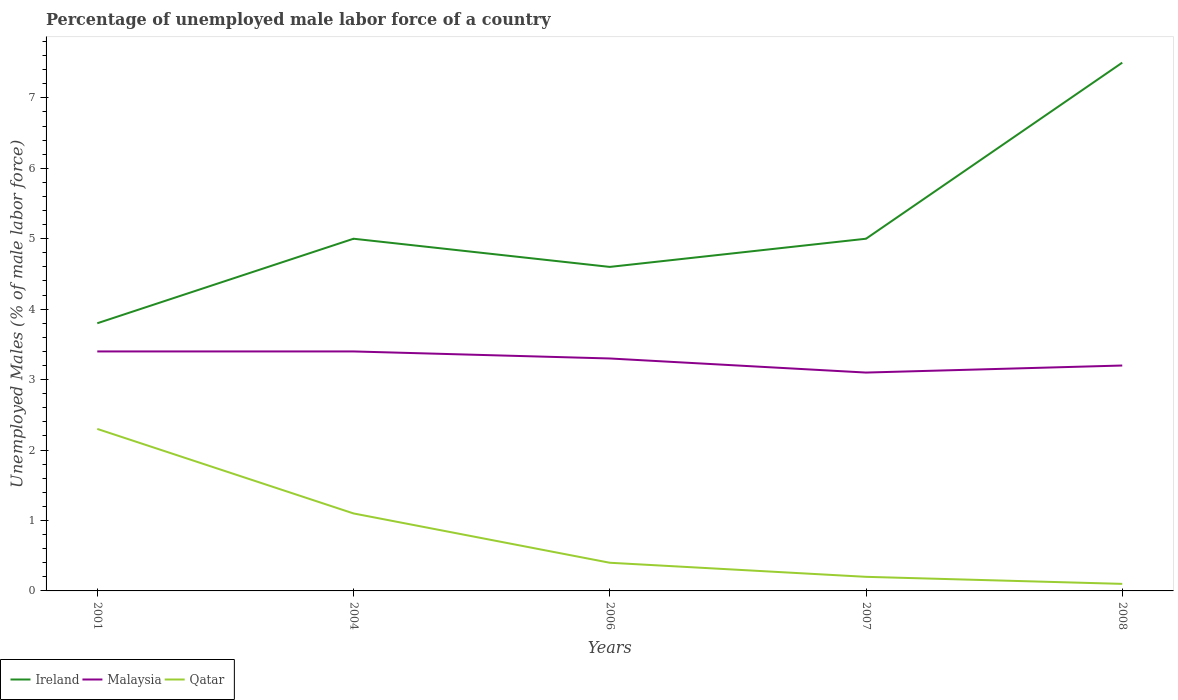How many different coloured lines are there?
Make the answer very short. 3. Is the number of lines equal to the number of legend labels?
Your answer should be very brief. Yes. Across all years, what is the maximum percentage of unemployed male labor force in Ireland?
Your answer should be compact. 3.8. In which year was the percentage of unemployed male labor force in Qatar maximum?
Your response must be concise. 2008. What is the total percentage of unemployed male labor force in Qatar in the graph?
Your answer should be compact. 1. What is the difference between the highest and the second highest percentage of unemployed male labor force in Qatar?
Offer a terse response. 2.2. What is the difference between the highest and the lowest percentage of unemployed male labor force in Ireland?
Your response must be concise. 1. Is the percentage of unemployed male labor force in Ireland strictly greater than the percentage of unemployed male labor force in Malaysia over the years?
Offer a terse response. No. How many years are there in the graph?
Make the answer very short. 5. Does the graph contain any zero values?
Your response must be concise. No. Where does the legend appear in the graph?
Your answer should be compact. Bottom left. How many legend labels are there?
Give a very brief answer. 3. What is the title of the graph?
Your answer should be compact. Percentage of unemployed male labor force of a country. Does "Austria" appear as one of the legend labels in the graph?
Your response must be concise. No. What is the label or title of the X-axis?
Provide a short and direct response. Years. What is the label or title of the Y-axis?
Your response must be concise. Unemployed Males (% of male labor force). What is the Unemployed Males (% of male labor force) in Ireland in 2001?
Make the answer very short. 3.8. What is the Unemployed Males (% of male labor force) of Malaysia in 2001?
Your answer should be compact. 3.4. What is the Unemployed Males (% of male labor force) of Qatar in 2001?
Your response must be concise. 2.3. What is the Unemployed Males (% of male labor force) in Ireland in 2004?
Offer a terse response. 5. What is the Unemployed Males (% of male labor force) of Malaysia in 2004?
Your response must be concise. 3.4. What is the Unemployed Males (% of male labor force) of Qatar in 2004?
Your response must be concise. 1.1. What is the Unemployed Males (% of male labor force) in Ireland in 2006?
Ensure brevity in your answer.  4.6. What is the Unemployed Males (% of male labor force) in Malaysia in 2006?
Provide a succinct answer. 3.3. What is the Unemployed Males (% of male labor force) in Qatar in 2006?
Offer a terse response. 0.4. What is the Unemployed Males (% of male labor force) of Ireland in 2007?
Your answer should be very brief. 5. What is the Unemployed Males (% of male labor force) in Malaysia in 2007?
Ensure brevity in your answer.  3.1. What is the Unemployed Males (% of male labor force) in Qatar in 2007?
Provide a succinct answer. 0.2. What is the Unemployed Males (% of male labor force) of Malaysia in 2008?
Offer a terse response. 3.2. What is the Unemployed Males (% of male labor force) in Qatar in 2008?
Provide a succinct answer. 0.1. Across all years, what is the maximum Unemployed Males (% of male labor force) in Malaysia?
Provide a short and direct response. 3.4. Across all years, what is the maximum Unemployed Males (% of male labor force) in Qatar?
Keep it short and to the point. 2.3. Across all years, what is the minimum Unemployed Males (% of male labor force) of Ireland?
Your response must be concise. 3.8. Across all years, what is the minimum Unemployed Males (% of male labor force) of Malaysia?
Give a very brief answer. 3.1. Across all years, what is the minimum Unemployed Males (% of male labor force) of Qatar?
Offer a terse response. 0.1. What is the total Unemployed Males (% of male labor force) in Ireland in the graph?
Provide a succinct answer. 25.9. What is the total Unemployed Males (% of male labor force) of Malaysia in the graph?
Provide a short and direct response. 16.4. What is the difference between the Unemployed Males (% of male labor force) of Malaysia in 2001 and that in 2004?
Your answer should be compact. 0. What is the difference between the Unemployed Males (% of male labor force) of Ireland in 2001 and that in 2006?
Ensure brevity in your answer.  -0.8. What is the difference between the Unemployed Males (% of male labor force) of Malaysia in 2001 and that in 2006?
Your answer should be very brief. 0.1. What is the difference between the Unemployed Males (% of male labor force) of Qatar in 2001 and that in 2006?
Your response must be concise. 1.9. What is the difference between the Unemployed Males (% of male labor force) of Malaysia in 2001 and that in 2007?
Provide a succinct answer. 0.3. What is the difference between the Unemployed Males (% of male labor force) in Qatar in 2001 and that in 2007?
Offer a very short reply. 2.1. What is the difference between the Unemployed Males (% of male labor force) of Malaysia in 2001 and that in 2008?
Give a very brief answer. 0.2. What is the difference between the Unemployed Males (% of male labor force) of Malaysia in 2004 and that in 2006?
Provide a succinct answer. 0.1. What is the difference between the Unemployed Males (% of male labor force) in Qatar in 2004 and that in 2006?
Offer a terse response. 0.7. What is the difference between the Unemployed Males (% of male labor force) in Qatar in 2004 and that in 2007?
Offer a terse response. 0.9. What is the difference between the Unemployed Males (% of male labor force) in Malaysia in 2004 and that in 2008?
Keep it short and to the point. 0.2. What is the difference between the Unemployed Males (% of male labor force) of Qatar in 2004 and that in 2008?
Your answer should be very brief. 1. What is the difference between the Unemployed Males (% of male labor force) in Malaysia in 2006 and that in 2007?
Your response must be concise. 0.2. What is the difference between the Unemployed Males (% of male labor force) in Ireland in 2006 and that in 2008?
Make the answer very short. -2.9. What is the difference between the Unemployed Males (% of male labor force) of Malaysia in 2006 and that in 2008?
Provide a succinct answer. 0.1. What is the difference between the Unemployed Males (% of male labor force) in Ireland in 2007 and that in 2008?
Give a very brief answer. -2.5. What is the difference between the Unemployed Males (% of male labor force) of Malaysia in 2007 and that in 2008?
Your answer should be compact. -0.1. What is the difference between the Unemployed Males (% of male labor force) in Qatar in 2007 and that in 2008?
Your response must be concise. 0.1. What is the difference between the Unemployed Males (% of male labor force) of Ireland in 2001 and the Unemployed Males (% of male labor force) of Malaysia in 2004?
Give a very brief answer. 0.4. What is the difference between the Unemployed Males (% of male labor force) of Ireland in 2001 and the Unemployed Males (% of male labor force) of Malaysia in 2006?
Your response must be concise. 0.5. What is the difference between the Unemployed Males (% of male labor force) in Malaysia in 2001 and the Unemployed Males (% of male labor force) in Qatar in 2006?
Keep it short and to the point. 3. What is the difference between the Unemployed Males (% of male labor force) in Ireland in 2001 and the Unemployed Males (% of male labor force) in Qatar in 2008?
Keep it short and to the point. 3.7. What is the difference between the Unemployed Males (% of male labor force) in Malaysia in 2001 and the Unemployed Males (% of male labor force) in Qatar in 2008?
Your answer should be compact. 3.3. What is the difference between the Unemployed Males (% of male labor force) of Malaysia in 2004 and the Unemployed Males (% of male labor force) of Qatar in 2007?
Offer a very short reply. 3.2. What is the difference between the Unemployed Males (% of male labor force) of Ireland in 2004 and the Unemployed Males (% of male labor force) of Malaysia in 2008?
Your answer should be compact. 1.8. What is the difference between the Unemployed Males (% of male labor force) of Ireland in 2004 and the Unemployed Males (% of male labor force) of Qatar in 2008?
Your answer should be compact. 4.9. What is the difference between the Unemployed Males (% of male labor force) of Ireland in 2006 and the Unemployed Males (% of male labor force) of Qatar in 2008?
Your response must be concise. 4.5. What is the difference between the Unemployed Males (% of male labor force) of Ireland in 2007 and the Unemployed Males (% of male labor force) of Malaysia in 2008?
Offer a very short reply. 1.8. What is the difference between the Unemployed Males (% of male labor force) in Malaysia in 2007 and the Unemployed Males (% of male labor force) in Qatar in 2008?
Offer a terse response. 3. What is the average Unemployed Males (% of male labor force) of Ireland per year?
Give a very brief answer. 5.18. What is the average Unemployed Males (% of male labor force) in Malaysia per year?
Offer a very short reply. 3.28. What is the average Unemployed Males (% of male labor force) in Qatar per year?
Keep it short and to the point. 0.82. In the year 2001, what is the difference between the Unemployed Males (% of male labor force) of Ireland and Unemployed Males (% of male labor force) of Malaysia?
Keep it short and to the point. 0.4. In the year 2001, what is the difference between the Unemployed Males (% of male labor force) in Ireland and Unemployed Males (% of male labor force) in Qatar?
Offer a very short reply. 1.5. In the year 2001, what is the difference between the Unemployed Males (% of male labor force) in Malaysia and Unemployed Males (% of male labor force) in Qatar?
Ensure brevity in your answer.  1.1. In the year 2004, what is the difference between the Unemployed Males (% of male labor force) in Ireland and Unemployed Males (% of male labor force) in Malaysia?
Keep it short and to the point. 1.6. In the year 2006, what is the difference between the Unemployed Males (% of male labor force) of Ireland and Unemployed Males (% of male labor force) of Malaysia?
Your answer should be very brief. 1.3. In the year 2006, what is the difference between the Unemployed Males (% of male labor force) of Malaysia and Unemployed Males (% of male labor force) of Qatar?
Provide a succinct answer. 2.9. In the year 2008, what is the difference between the Unemployed Males (% of male labor force) in Malaysia and Unemployed Males (% of male labor force) in Qatar?
Your answer should be very brief. 3.1. What is the ratio of the Unemployed Males (% of male labor force) of Ireland in 2001 to that in 2004?
Ensure brevity in your answer.  0.76. What is the ratio of the Unemployed Males (% of male labor force) in Malaysia in 2001 to that in 2004?
Your answer should be compact. 1. What is the ratio of the Unemployed Males (% of male labor force) of Qatar in 2001 to that in 2004?
Your answer should be very brief. 2.09. What is the ratio of the Unemployed Males (% of male labor force) in Ireland in 2001 to that in 2006?
Your response must be concise. 0.83. What is the ratio of the Unemployed Males (% of male labor force) of Malaysia in 2001 to that in 2006?
Your response must be concise. 1.03. What is the ratio of the Unemployed Males (% of male labor force) of Qatar in 2001 to that in 2006?
Your response must be concise. 5.75. What is the ratio of the Unemployed Males (% of male labor force) in Ireland in 2001 to that in 2007?
Provide a succinct answer. 0.76. What is the ratio of the Unemployed Males (% of male labor force) of Malaysia in 2001 to that in 2007?
Your answer should be compact. 1.1. What is the ratio of the Unemployed Males (% of male labor force) of Ireland in 2001 to that in 2008?
Make the answer very short. 0.51. What is the ratio of the Unemployed Males (% of male labor force) of Malaysia in 2001 to that in 2008?
Your answer should be very brief. 1.06. What is the ratio of the Unemployed Males (% of male labor force) of Ireland in 2004 to that in 2006?
Your answer should be compact. 1.09. What is the ratio of the Unemployed Males (% of male labor force) in Malaysia in 2004 to that in 2006?
Your response must be concise. 1.03. What is the ratio of the Unemployed Males (% of male labor force) of Qatar in 2004 to that in 2006?
Offer a very short reply. 2.75. What is the ratio of the Unemployed Males (% of male labor force) of Malaysia in 2004 to that in 2007?
Your response must be concise. 1.1. What is the ratio of the Unemployed Males (% of male labor force) of Ireland in 2004 to that in 2008?
Your answer should be compact. 0.67. What is the ratio of the Unemployed Males (% of male labor force) of Malaysia in 2004 to that in 2008?
Make the answer very short. 1.06. What is the ratio of the Unemployed Males (% of male labor force) in Ireland in 2006 to that in 2007?
Your answer should be compact. 0.92. What is the ratio of the Unemployed Males (% of male labor force) of Malaysia in 2006 to that in 2007?
Provide a short and direct response. 1.06. What is the ratio of the Unemployed Males (% of male labor force) in Qatar in 2006 to that in 2007?
Provide a short and direct response. 2. What is the ratio of the Unemployed Males (% of male labor force) in Ireland in 2006 to that in 2008?
Provide a short and direct response. 0.61. What is the ratio of the Unemployed Males (% of male labor force) of Malaysia in 2006 to that in 2008?
Make the answer very short. 1.03. What is the ratio of the Unemployed Males (% of male labor force) in Malaysia in 2007 to that in 2008?
Offer a very short reply. 0.97. What is the difference between the highest and the second highest Unemployed Males (% of male labor force) of Qatar?
Ensure brevity in your answer.  1.2. 